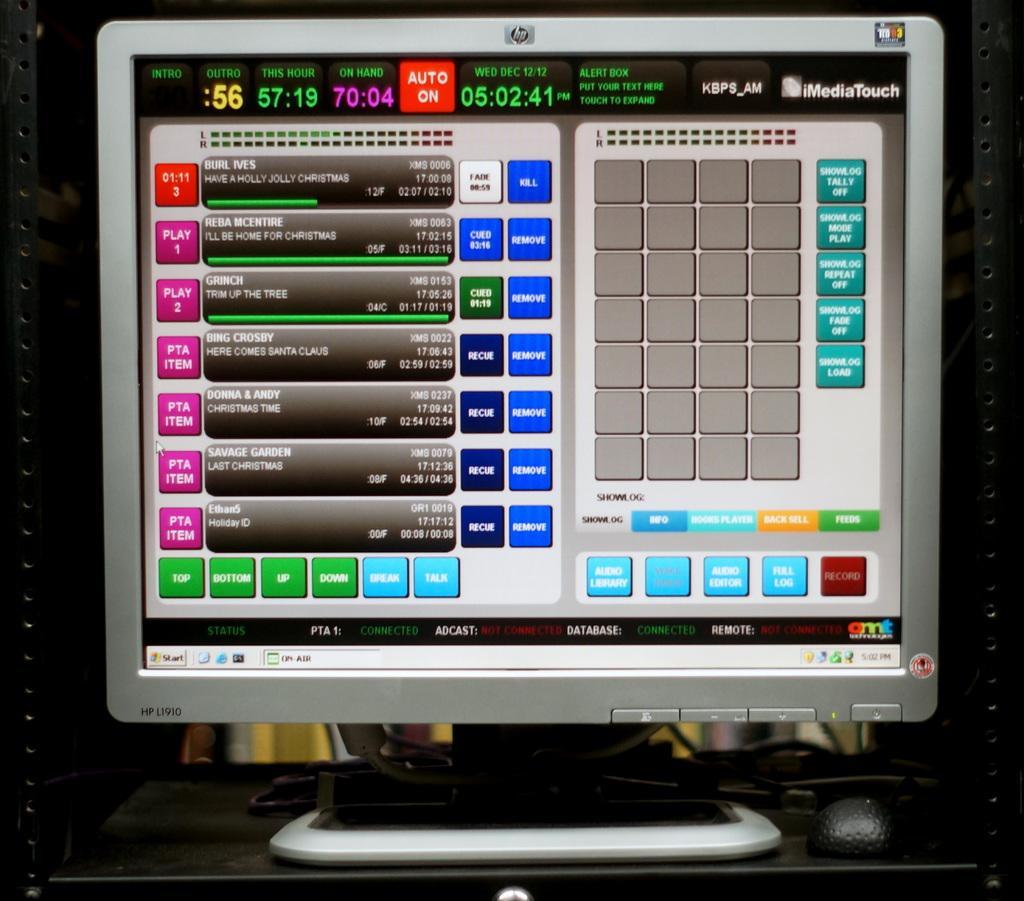Please provide a concise description of this image. In this image we can see a monitor on the object. On the monitor screen, there are letters and numbers. Monitor consists of some keys. On the object there is a mouse and wires. On the left and right side of the image there are iron objects. 